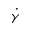Convert formula to latex. <formula><loc_0><loc_0><loc_500><loc_500>\dot { \gamma }</formula> 